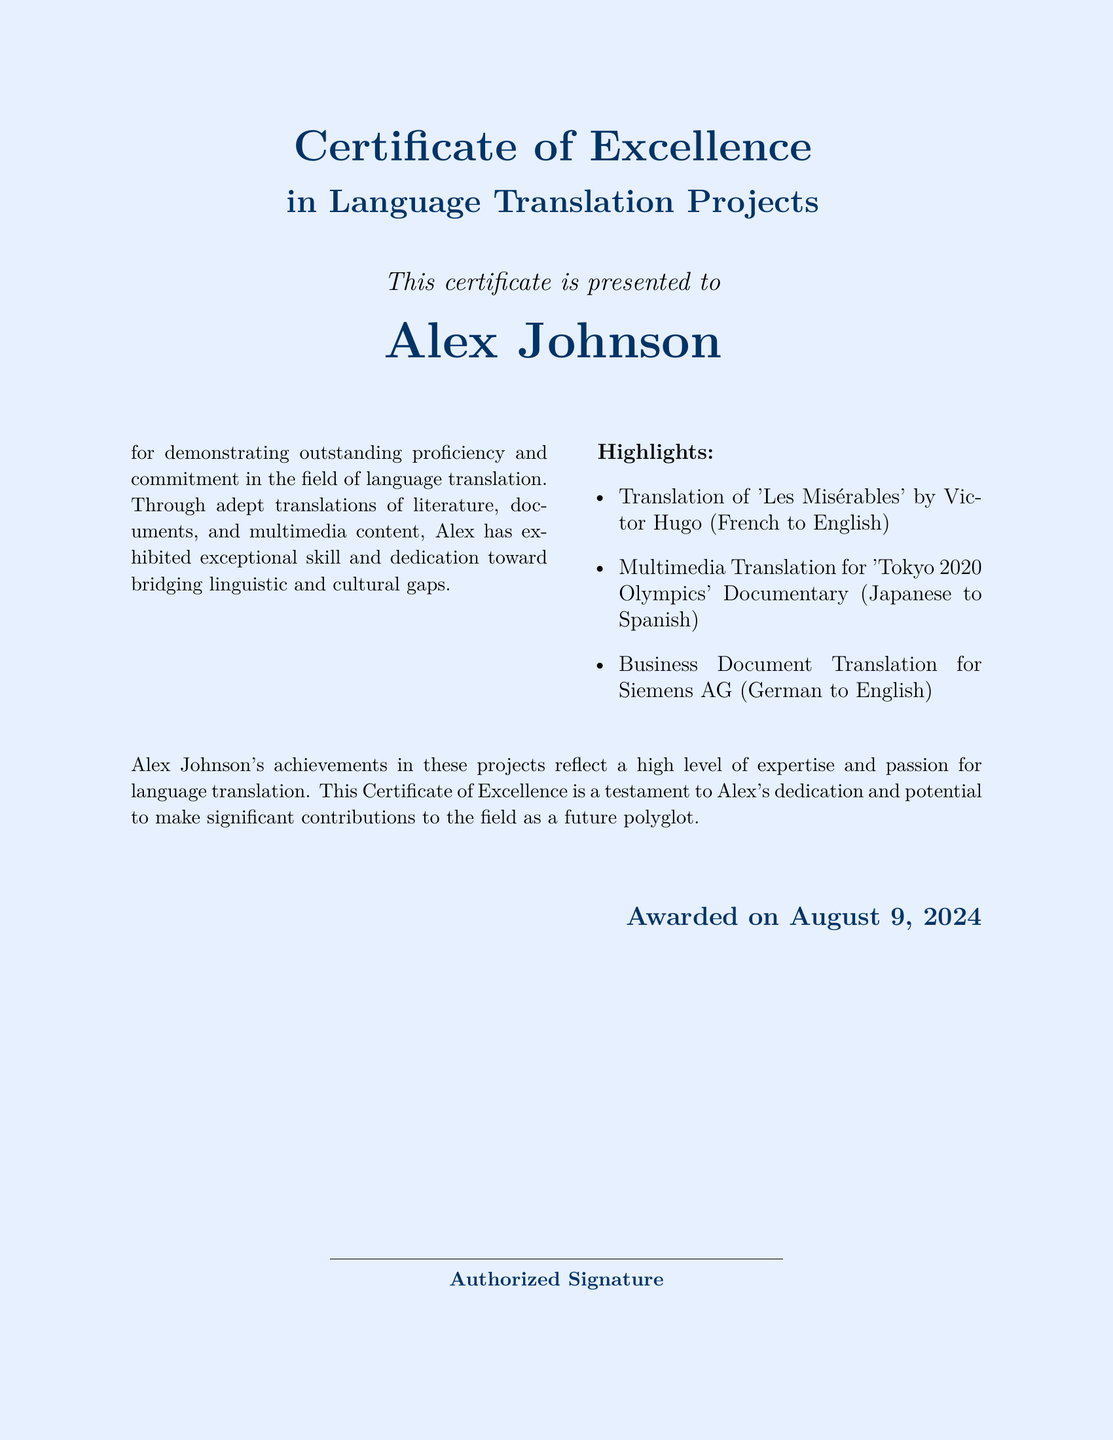What is the title of the certificate? The title of the certificate can be found at the top of the document, indicating the achievement of the recipient.
Answer: Certificate of Excellence Who is the recipient of the certificate? The certificate specifies the name of the individual who has received this recognition prominently in the center.
Answer: Alex Johnson What project involved translating a book by Victor Hugo? The document lists this specific project as one of the highlights of the recipient's achievements.
Answer: Translation of 'Les Misérables' What languages were involved in the multimedia translation project for the Tokyo 2020 Olympics? The certificate mentions the source and target languages for this project, providing insight into the linguistic skills applied.
Answer: Japanese to Spanish When was the certificate awarded? The date of the award is indicated at the bottom of the document.
Answer: Today What type of document was translated for Siemens AG? The document highlights the nature of the translation work completed for this specific company.
Answer: Business Document Translation What is the purpose of the certificate? The certificate explicitly states its purpose related to the recipient's achievements in language translation.
Answer: To recognize outstanding proficiency and commitment What does the certificate suggest about Alex Johnson's future? The concluding section of the certificate provides insight into the recipient's potential moving forward within the field.
Answer: Future polyglot 